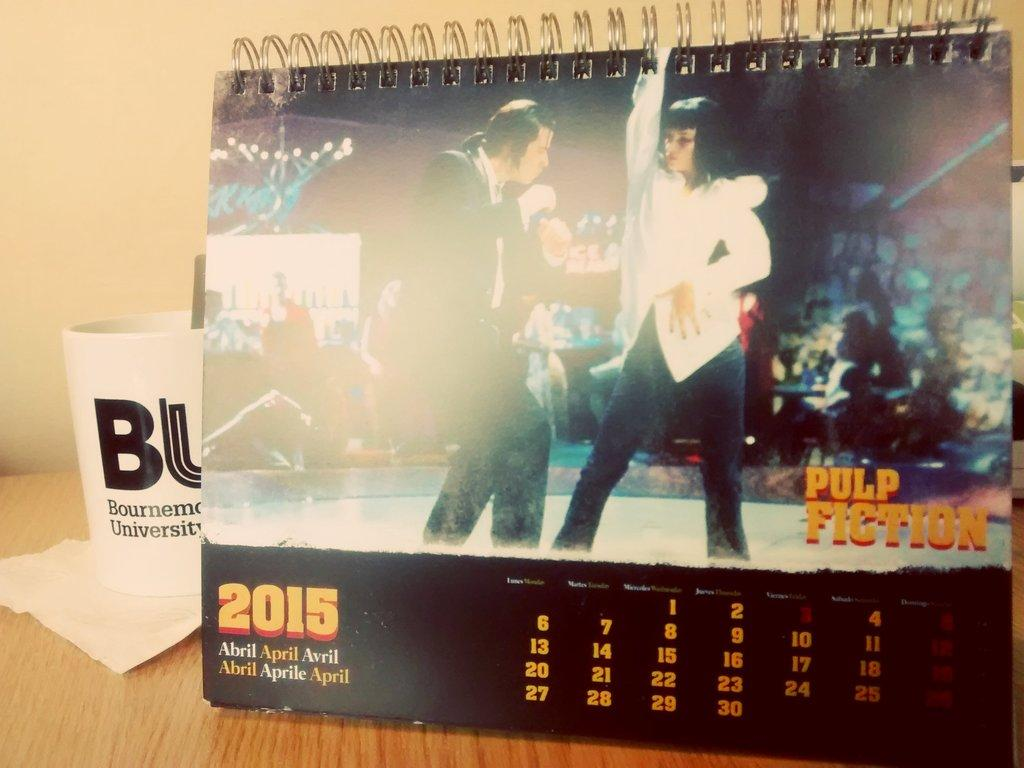What type of surface is visible in the image? There is a wooden surface in the image. What is placed on the wooden surface? There is a calendar on the wooden surface. What else can be seen on the wooden surface? There is a paper with a cup on it in the image. What is visible in the background of the image? There is a wall in the background of the image. What color is the grape that is causing the calendar to fall off the wooden surface? There is no grape present in the image, and the calendar is not falling off the wooden surface. 